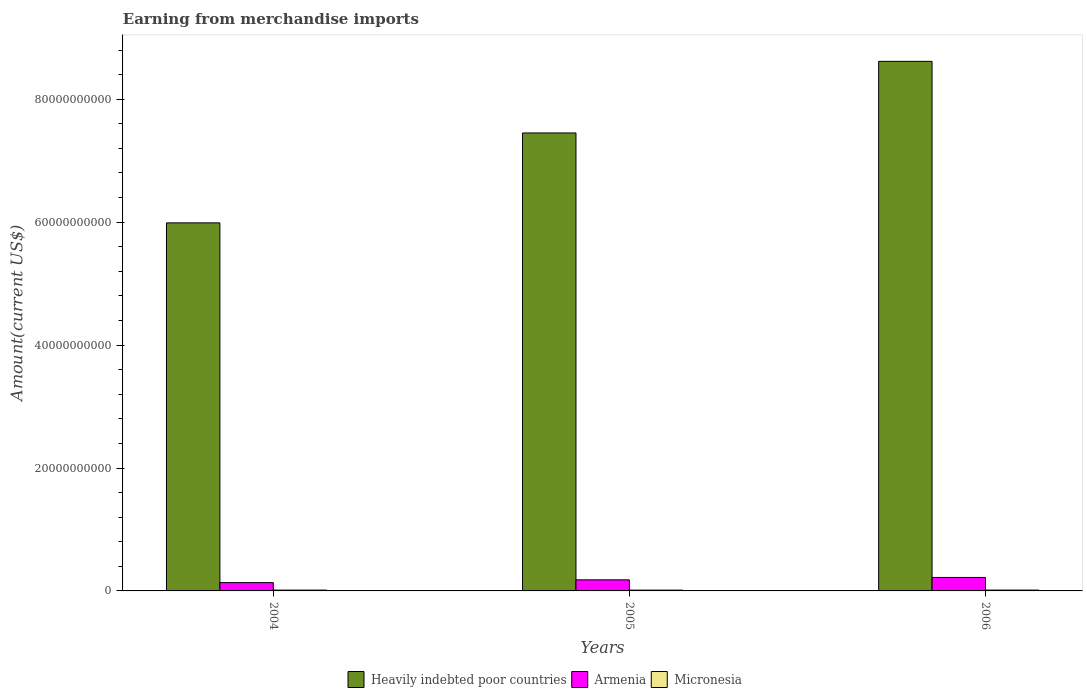How many different coloured bars are there?
Your answer should be very brief. 3. Are the number of bars on each tick of the X-axis equal?
Give a very brief answer. Yes. How many bars are there on the 3rd tick from the left?
Provide a succinct answer. 3. In how many cases, is the number of bars for a given year not equal to the number of legend labels?
Offer a terse response. 0. What is the amount earned from merchandise imports in Micronesia in 2006?
Your response must be concise. 1.37e+08. Across all years, what is the maximum amount earned from merchandise imports in Heavily indebted poor countries?
Ensure brevity in your answer.  8.62e+1. Across all years, what is the minimum amount earned from merchandise imports in Armenia?
Ensure brevity in your answer.  1.35e+09. What is the total amount earned from merchandise imports in Micronesia in the graph?
Offer a very short reply. 4.00e+08. What is the difference between the amount earned from merchandise imports in Armenia in 2005 and that in 2006?
Your answer should be very brief. -3.90e+08. What is the difference between the amount earned from merchandise imports in Armenia in 2005 and the amount earned from merchandise imports in Heavily indebted poor countries in 2004?
Provide a short and direct response. -5.81e+1. What is the average amount earned from merchandise imports in Micronesia per year?
Offer a very short reply. 1.33e+08. In the year 2004, what is the difference between the amount earned from merchandise imports in Heavily indebted poor countries and amount earned from merchandise imports in Armenia?
Give a very brief answer. 5.85e+1. What is the ratio of the amount earned from merchandise imports in Armenia in 2004 to that in 2005?
Your answer should be compact. 0.75. What is the difference between the highest and the second highest amount earned from merchandise imports in Armenia?
Provide a short and direct response. 3.90e+08. What is the difference between the highest and the lowest amount earned from merchandise imports in Armenia?
Ensure brevity in your answer.  8.41e+08. In how many years, is the amount earned from merchandise imports in Micronesia greater than the average amount earned from merchandise imports in Micronesia taken over all years?
Ensure brevity in your answer.  1. What does the 1st bar from the left in 2006 represents?
Your response must be concise. Heavily indebted poor countries. What does the 3rd bar from the right in 2005 represents?
Give a very brief answer. Heavily indebted poor countries. How many years are there in the graph?
Your answer should be compact. 3. What is the difference between two consecutive major ticks on the Y-axis?
Provide a short and direct response. 2.00e+1. Are the values on the major ticks of Y-axis written in scientific E-notation?
Ensure brevity in your answer.  No. Does the graph contain grids?
Provide a short and direct response. No. What is the title of the graph?
Ensure brevity in your answer.  Earning from merchandise imports. Does "Tanzania" appear as one of the legend labels in the graph?
Ensure brevity in your answer.  No. What is the label or title of the X-axis?
Your answer should be very brief. Years. What is the label or title of the Y-axis?
Your answer should be very brief. Amount(current US$). What is the Amount(current US$) in Heavily indebted poor countries in 2004?
Ensure brevity in your answer.  5.99e+1. What is the Amount(current US$) of Armenia in 2004?
Make the answer very short. 1.35e+09. What is the Amount(current US$) in Micronesia in 2004?
Offer a very short reply. 1.33e+08. What is the Amount(current US$) in Heavily indebted poor countries in 2005?
Keep it short and to the point. 7.45e+1. What is the Amount(current US$) of Armenia in 2005?
Make the answer very short. 1.80e+09. What is the Amount(current US$) of Micronesia in 2005?
Give a very brief answer. 1.30e+08. What is the Amount(current US$) of Heavily indebted poor countries in 2006?
Give a very brief answer. 8.62e+1. What is the Amount(current US$) of Armenia in 2006?
Make the answer very short. 2.19e+09. What is the Amount(current US$) of Micronesia in 2006?
Your answer should be very brief. 1.37e+08. Across all years, what is the maximum Amount(current US$) in Heavily indebted poor countries?
Your response must be concise. 8.62e+1. Across all years, what is the maximum Amount(current US$) in Armenia?
Your response must be concise. 2.19e+09. Across all years, what is the maximum Amount(current US$) in Micronesia?
Offer a very short reply. 1.37e+08. Across all years, what is the minimum Amount(current US$) in Heavily indebted poor countries?
Provide a short and direct response. 5.99e+1. Across all years, what is the minimum Amount(current US$) of Armenia?
Keep it short and to the point. 1.35e+09. Across all years, what is the minimum Amount(current US$) in Micronesia?
Provide a short and direct response. 1.30e+08. What is the total Amount(current US$) in Heavily indebted poor countries in the graph?
Offer a very short reply. 2.21e+11. What is the total Amount(current US$) of Armenia in the graph?
Provide a short and direct response. 5.34e+09. What is the total Amount(current US$) of Micronesia in the graph?
Ensure brevity in your answer.  4.00e+08. What is the difference between the Amount(current US$) of Heavily indebted poor countries in 2004 and that in 2005?
Keep it short and to the point. -1.46e+1. What is the difference between the Amount(current US$) in Armenia in 2004 and that in 2005?
Your answer should be very brief. -4.51e+08. What is the difference between the Amount(current US$) in Micronesia in 2004 and that in 2005?
Your answer should be compact. 2.48e+06. What is the difference between the Amount(current US$) in Heavily indebted poor countries in 2004 and that in 2006?
Your answer should be compact. -2.63e+1. What is the difference between the Amount(current US$) of Armenia in 2004 and that in 2006?
Offer a very short reply. -8.41e+08. What is the difference between the Amount(current US$) in Micronesia in 2004 and that in 2006?
Offer a very short reply. -4.06e+06. What is the difference between the Amount(current US$) in Heavily indebted poor countries in 2005 and that in 2006?
Your answer should be very brief. -1.17e+1. What is the difference between the Amount(current US$) of Armenia in 2005 and that in 2006?
Provide a short and direct response. -3.90e+08. What is the difference between the Amount(current US$) in Micronesia in 2005 and that in 2006?
Ensure brevity in your answer.  -6.54e+06. What is the difference between the Amount(current US$) in Heavily indebted poor countries in 2004 and the Amount(current US$) in Armenia in 2005?
Your response must be concise. 5.81e+1. What is the difference between the Amount(current US$) in Heavily indebted poor countries in 2004 and the Amount(current US$) in Micronesia in 2005?
Ensure brevity in your answer.  5.98e+1. What is the difference between the Amount(current US$) of Armenia in 2004 and the Amount(current US$) of Micronesia in 2005?
Your response must be concise. 1.22e+09. What is the difference between the Amount(current US$) of Heavily indebted poor countries in 2004 and the Amount(current US$) of Armenia in 2006?
Offer a terse response. 5.77e+1. What is the difference between the Amount(current US$) of Heavily indebted poor countries in 2004 and the Amount(current US$) of Micronesia in 2006?
Provide a succinct answer. 5.97e+1. What is the difference between the Amount(current US$) of Armenia in 2004 and the Amount(current US$) of Micronesia in 2006?
Provide a succinct answer. 1.21e+09. What is the difference between the Amount(current US$) in Heavily indebted poor countries in 2005 and the Amount(current US$) in Armenia in 2006?
Ensure brevity in your answer.  7.23e+1. What is the difference between the Amount(current US$) in Heavily indebted poor countries in 2005 and the Amount(current US$) in Micronesia in 2006?
Provide a short and direct response. 7.44e+1. What is the difference between the Amount(current US$) of Armenia in 2005 and the Amount(current US$) of Micronesia in 2006?
Your response must be concise. 1.66e+09. What is the average Amount(current US$) of Heavily indebted poor countries per year?
Your response must be concise. 7.35e+1. What is the average Amount(current US$) of Armenia per year?
Your answer should be compact. 1.78e+09. What is the average Amount(current US$) in Micronesia per year?
Give a very brief answer. 1.33e+08. In the year 2004, what is the difference between the Amount(current US$) of Heavily indebted poor countries and Amount(current US$) of Armenia?
Your answer should be very brief. 5.85e+1. In the year 2004, what is the difference between the Amount(current US$) of Heavily indebted poor countries and Amount(current US$) of Micronesia?
Provide a short and direct response. 5.98e+1. In the year 2004, what is the difference between the Amount(current US$) of Armenia and Amount(current US$) of Micronesia?
Your answer should be compact. 1.22e+09. In the year 2005, what is the difference between the Amount(current US$) in Heavily indebted poor countries and Amount(current US$) in Armenia?
Your answer should be compact. 7.27e+1. In the year 2005, what is the difference between the Amount(current US$) in Heavily indebted poor countries and Amount(current US$) in Micronesia?
Your answer should be compact. 7.44e+1. In the year 2005, what is the difference between the Amount(current US$) of Armenia and Amount(current US$) of Micronesia?
Your response must be concise. 1.67e+09. In the year 2006, what is the difference between the Amount(current US$) of Heavily indebted poor countries and Amount(current US$) of Armenia?
Provide a succinct answer. 8.40e+1. In the year 2006, what is the difference between the Amount(current US$) in Heavily indebted poor countries and Amount(current US$) in Micronesia?
Your response must be concise. 8.60e+1. In the year 2006, what is the difference between the Amount(current US$) in Armenia and Amount(current US$) in Micronesia?
Offer a very short reply. 2.05e+09. What is the ratio of the Amount(current US$) of Heavily indebted poor countries in 2004 to that in 2005?
Ensure brevity in your answer.  0.8. What is the ratio of the Amount(current US$) in Armenia in 2004 to that in 2005?
Offer a very short reply. 0.75. What is the ratio of the Amount(current US$) of Micronesia in 2004 to that in 2005?
Offer a terse response. 1.02. What is the ratio of the Amount(current US$) in Heavily indebted poor countries in 2004 to that in 2006?
Give a very brief answer. 0.69. What is the ratio of the Amount(current US$) of Armenia in 2004 to that in 2006?
Give a very brief answer. 0.62. What is the ratio of the Amount(current US$) of Micronesia in 2004 to that in 2006?
Your response must be concise. 0.97. What is the ratio of the Amount(current US$) of Heavily indebted poor countries in 2005 to that in 2006?
Your answer should be compact. 0.86. What is the ratio of the Amount(current US$) of Armenia in 2005 to that in 2006?
Your response must be concise. 0.82. What is the ratio of the Amount(current US$) in Micronesia in 2005 to that in 2006?
Provide a short and direct response. 0.95. What is the difference between the highest and the second highest Amount(current US$) in Heavily indebted poor countries?
Provide a short and direct response. 1.17e+1. What is the difference between the highest and the second highest Amount(current US$) in Armenia?
Your answer should be very brief. 3.90e+08. What is the difference between the highest and the second highest Amount(current US$) in Micronesia?
Provide a succinct answer. 4.06e+06. What is the difference between the highest and the lowest Amount(current US$) of Heavily indebted poor countries?
Give a very brief answer. 2.63e+1. What is the difference between the highest and the lowest Amount(current US$) in Armenia?
Offer a terse response. 8.41e+08. What is the difference between the highest and the lowest Amount(current US$) of Micronesia?
Offer a very short reply. 6.54e+06. 